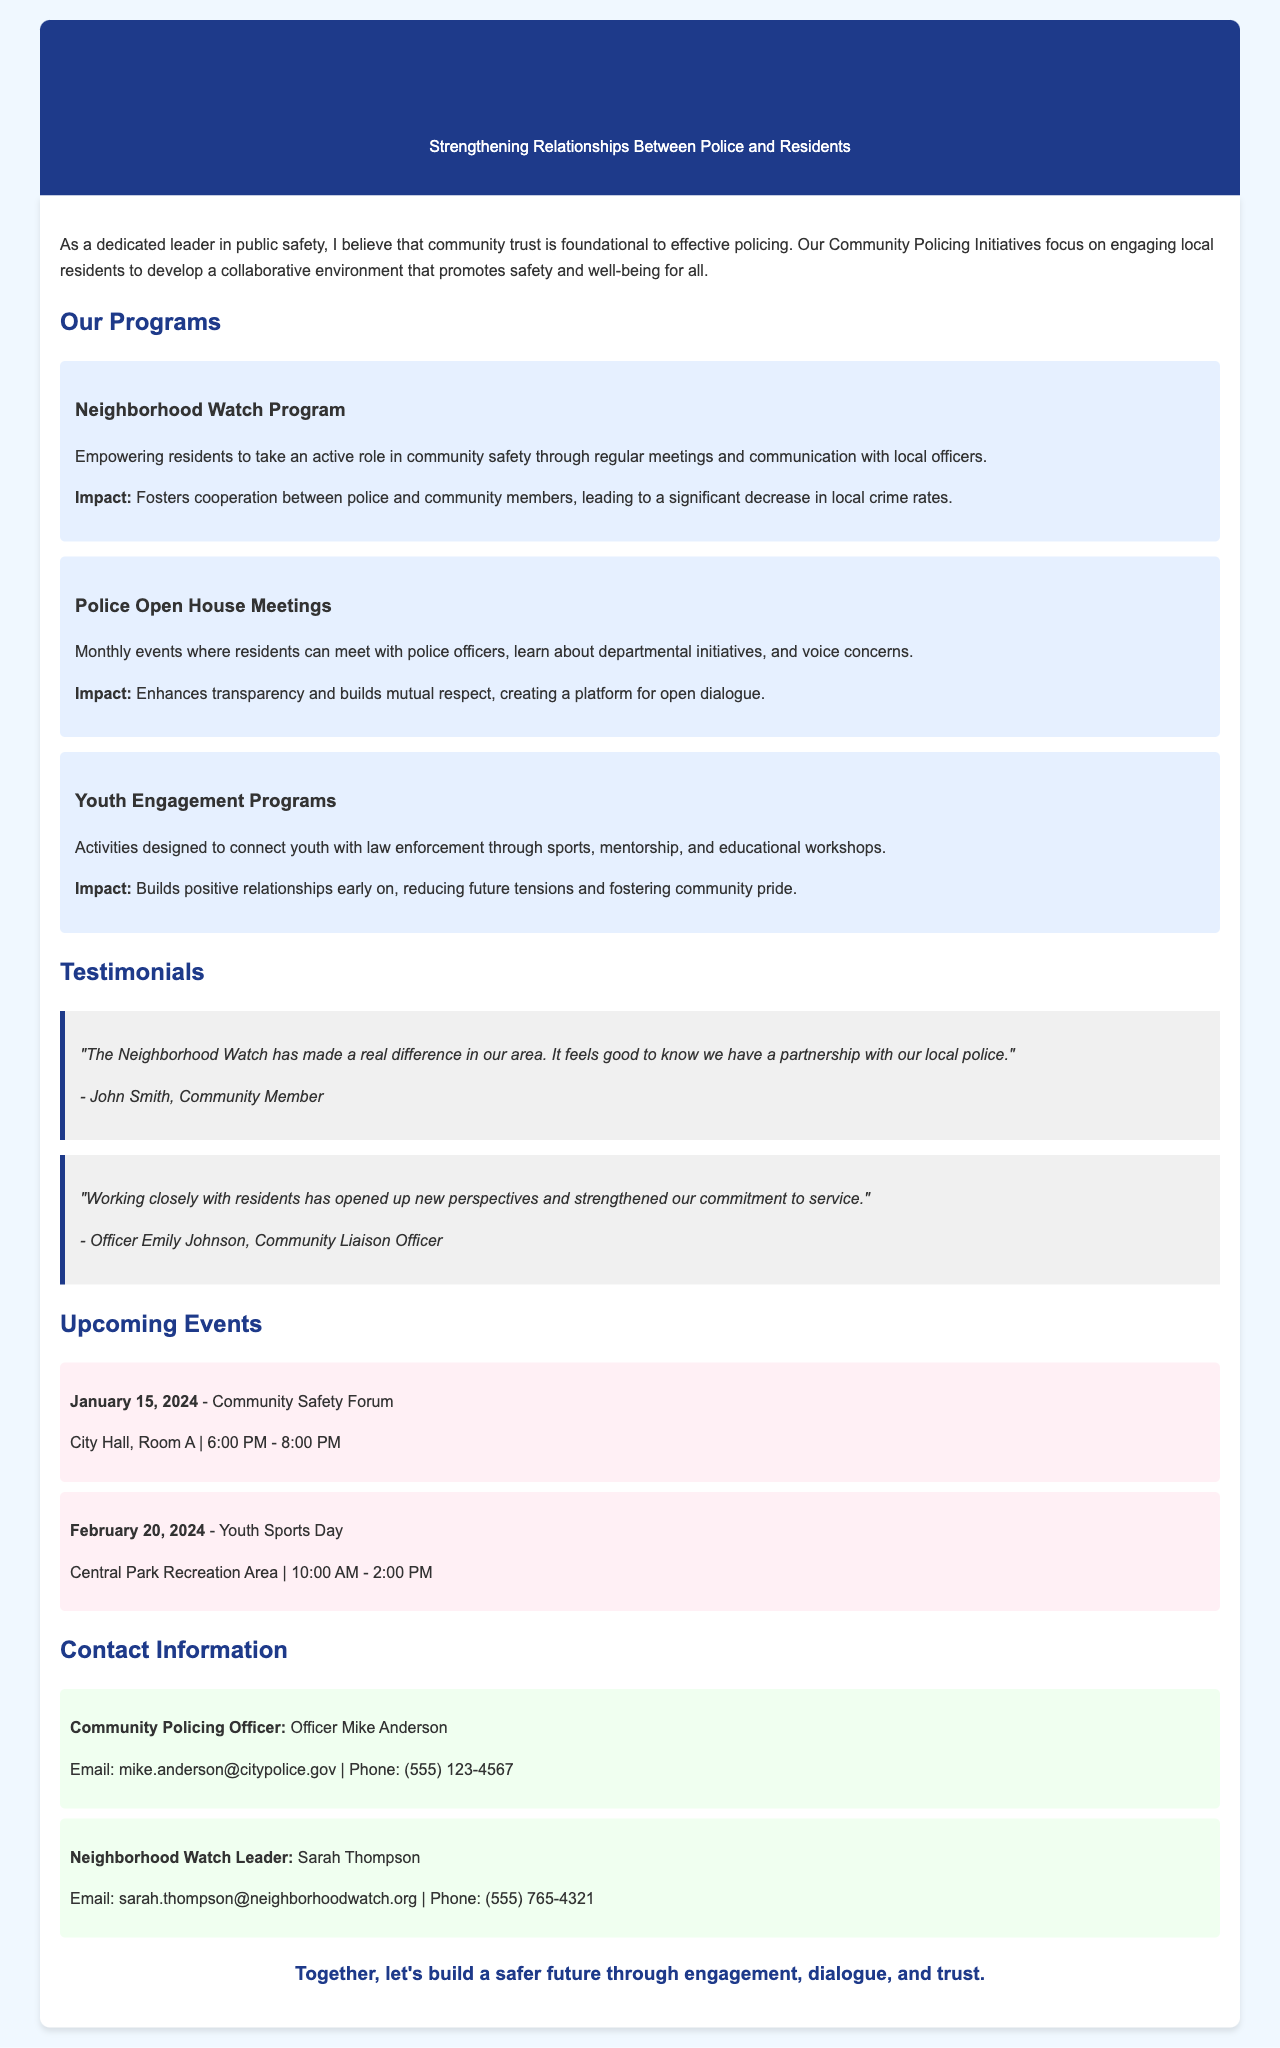What are the names of the community policing programs? The document lists several programs under "Our Programs," which include the Neighborhood Watch Program, Police Open House Meetings, and Youth Engagement Programs.
Answer: Neighborhood Watch Program, Police Open House Meetings, Youth Engagement Programs Who is the Community Policing Officer? The document specifies the contact information for two community leaders, identifying Officer Mike Anderson as the Community Policing Officer.
Answer: Officer Mike Anderson What date is the Community Safety Forum scheduled? The document provides an upcoming event, mentioning that the Community Safety Forum is scheduled for January 15, 2024.
Answer: January 15, 2024 What is the primary impact of the Youth Engagement Programs? The document states that the impact of the Youth Engagement Programs is to build positive relationships early on, which reduces future tensions and fosters community pride.
Answer: Builds positive relationships How does the Neighborhood Watch Program contribute to community safety? According to the document, the Neighborhood Watch Program empowers residents and fosters cooperation between police and community members, leading to a significant decrease in local crime rates.
Answer: Significant decrease in local crime rates When is the Youth Sports Day event? The document outlines the schedule for the Youth Sports Day event, which is on February 20, 2024.
Answer: February 20, 2024 What is the email address for the Neighborhood Watch Leader? The contact section of the document includes Sarah Thompson as the Neighborhood Watch Leader, and her email address is provided as sarah.thompson@neighborhoodwatch.org.
Answer: sarah.thompson@neighborhoodwatch.org What is the purpose of the Police Open House Meetings? The document describes the Police Open House Meetings as events where residents can meet with police officers, learn about initiatives, and voice concerns, enhancing transparency.
Answer: Enhances transparency What type of feedback does the testimonial from John Smith provide? The testimonial from John Smith expresses positivity about the Neighborhood Watch, indicating that it has made a real difference in his area.
Answer: Made a real difference 